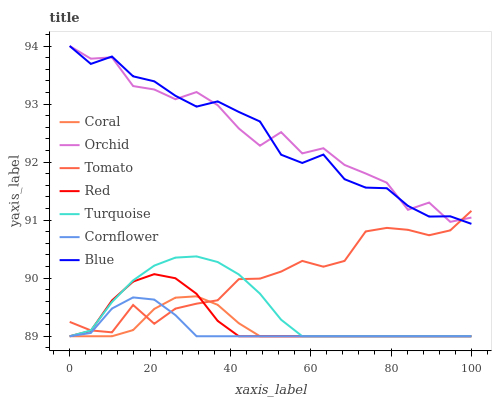Does Cornflower have the minimum area under the curve?
Answer yes or no. Yes. Does Orchid have the maximum area under the curve?
Answer yes or no. Yes. Does Turquoise have the minimum area under the curve?
Answer yes or no. No. Does Turquoise have the maximum area under the curve?
Answer yes or no. No. Is Coral the smoothest?
Answer yes or no. Yes. Is Orchid the roughest?
Answer yes or no. Yes. Is Cornflower the smoothest?
Answer yes or no. No. Is Cornflower the roughest?
Answer yes or no. No. Does Cornflower have the lowest value?
Answer yes or no. Yes. Does Blue have the lowest value?
Answer yes or no. No. Does Orchid have the highest value?
Answer yes or no. Yes. Does Turquoise have the highest value?
Answer yes or no. No. Is Turquoise less than Blue?
Answer yes or no. Yes. Is Orchid greater than Cornflower?
Answer yes or no. Yes. Does Coral intersect Red?
Answer yes or no. Yes. Is Coral less than Red?
Answer yes or no. No. Is Coral greater than Red?
Answer yes or no. No. Does Turquoise intersect Blue?
Answer yes or no. No. 